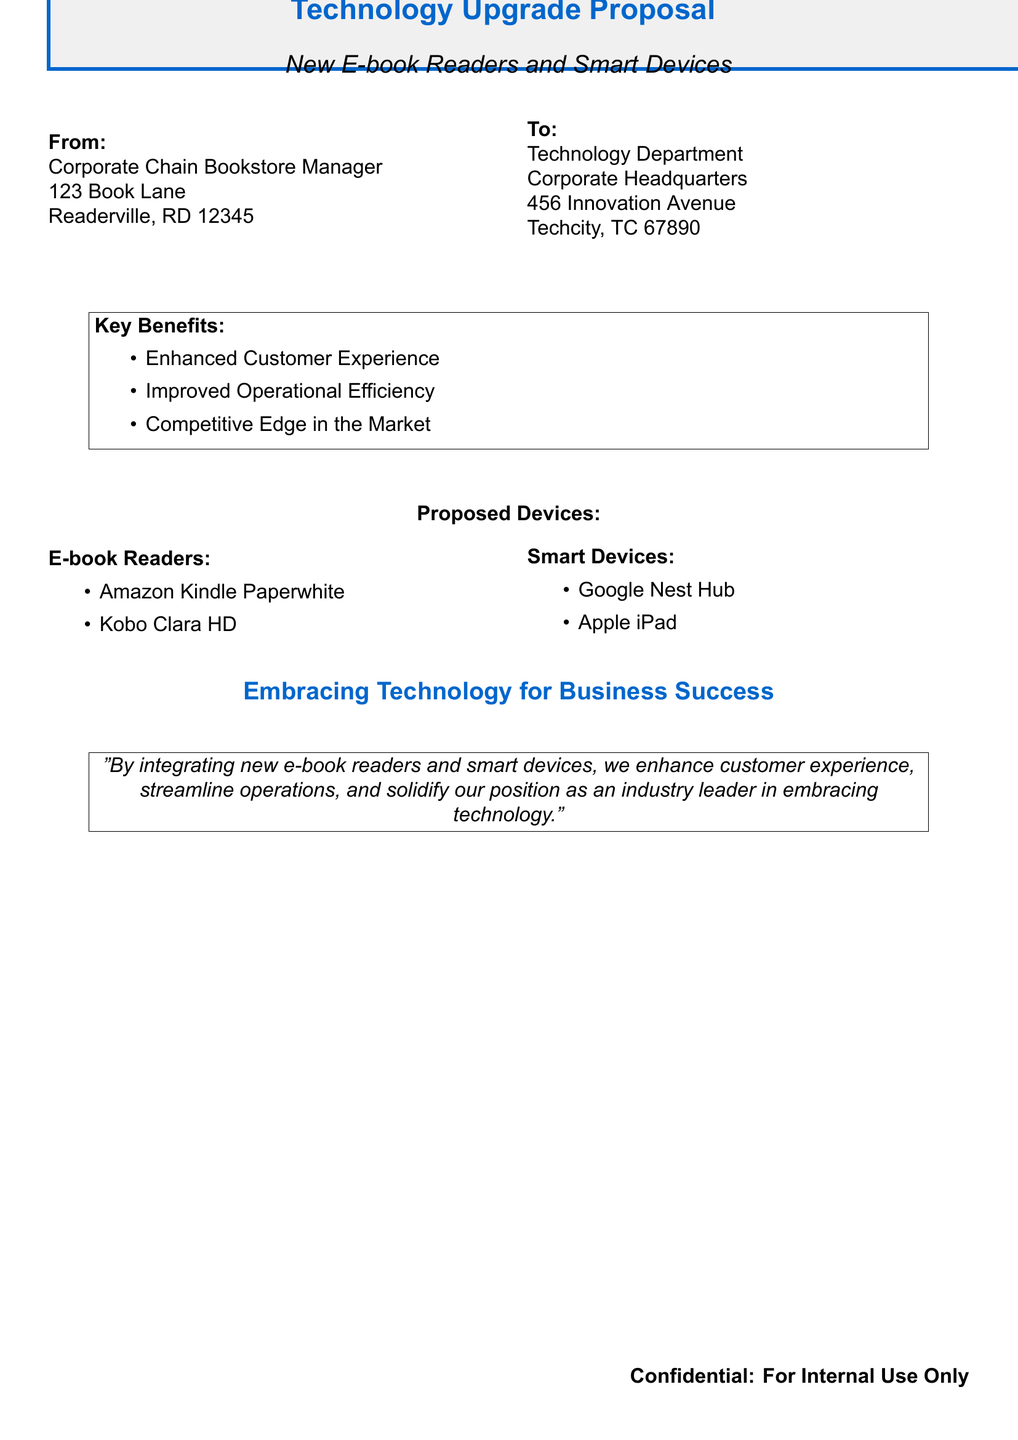What is the title of the document? The title of the document is stated prominently at the top and is "Technology Upgrade Proposal."
Answer: Technology Upgrade Proposal Who is the proposal addressed to? The proposal is addressed to a specific department at the corporate headquarters, which is the Technology Department.
Answer: Technology Department What are the proposed e-book readers? The document lists the proposed e-book readers, which include the Amazon Kindle Paperwhite and the Kobo Clara HD.
Answer: Amazon Kindle Paperwhite, Kobo Clara HD What is one key benefit mentioned? The document outlines several key benefits; one of them is "Enhanced Customer Experience."
Answer: Enhanced Customer Experience Which smart device is included in the proposal? The proposal lists two smart devices, one of which is the Google Nest Hub.
Answer: Google Nest Hub How many key benefits are listed in the document? The document presents three key benefits under the section titled "Key Benefits."
Answer: 3 What is the significance of installing new devices according to the proposal? The proposal notes that integrating new e-book readers and smart devices will enhance customer experience and streamline operations.
Answer: Enhance customer experience and streamline operations Is this document intended for external distribution? The document includes a confidentiality notice at the bottom stating it is "For Internal Use Only."
Answer: For Internal Use Only 